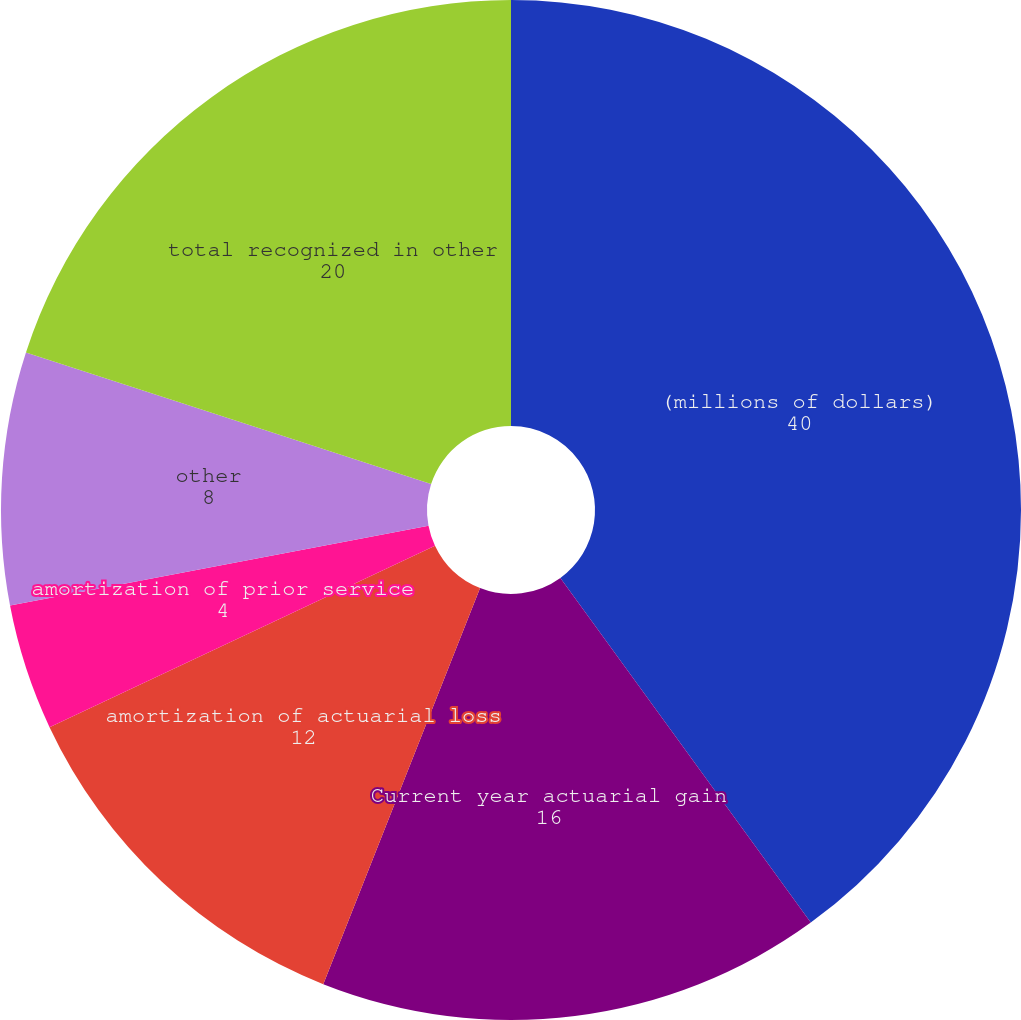Convert chart to OTSL. <chart><loc_0><loc_0><loc_500><loc_500><pie_chart><fcel>(millions of dollars)<fcel>Current year actuarial gain<fcel>amortization of actuarial loss<fcel>amortization of prior service<fcel>amortization of transition<fcel>other<fcel>total recognized in other<nl><fcel>40.0%<fcel>16.0%<fcel>12.0%<fcel>4.0%<fcel>0.0%<fcel>8.0%<fcel>20.0%<nl></chart> 